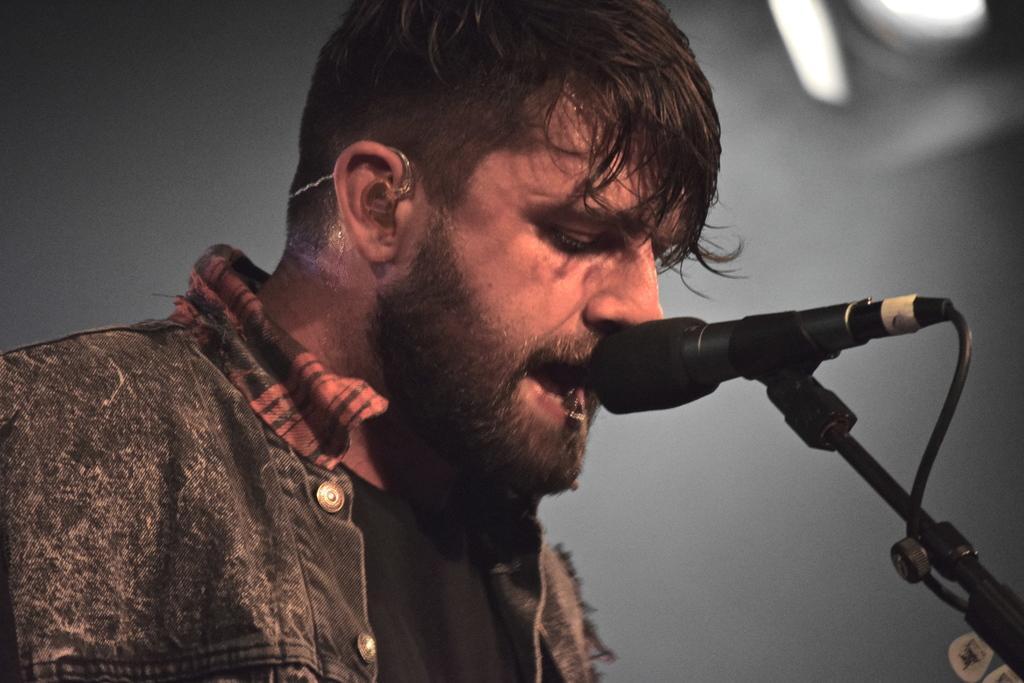Could you give a brief overview of what you see in this image? In this picture we can see a man and in front of him we can see a mic and in the background we can see a light. 